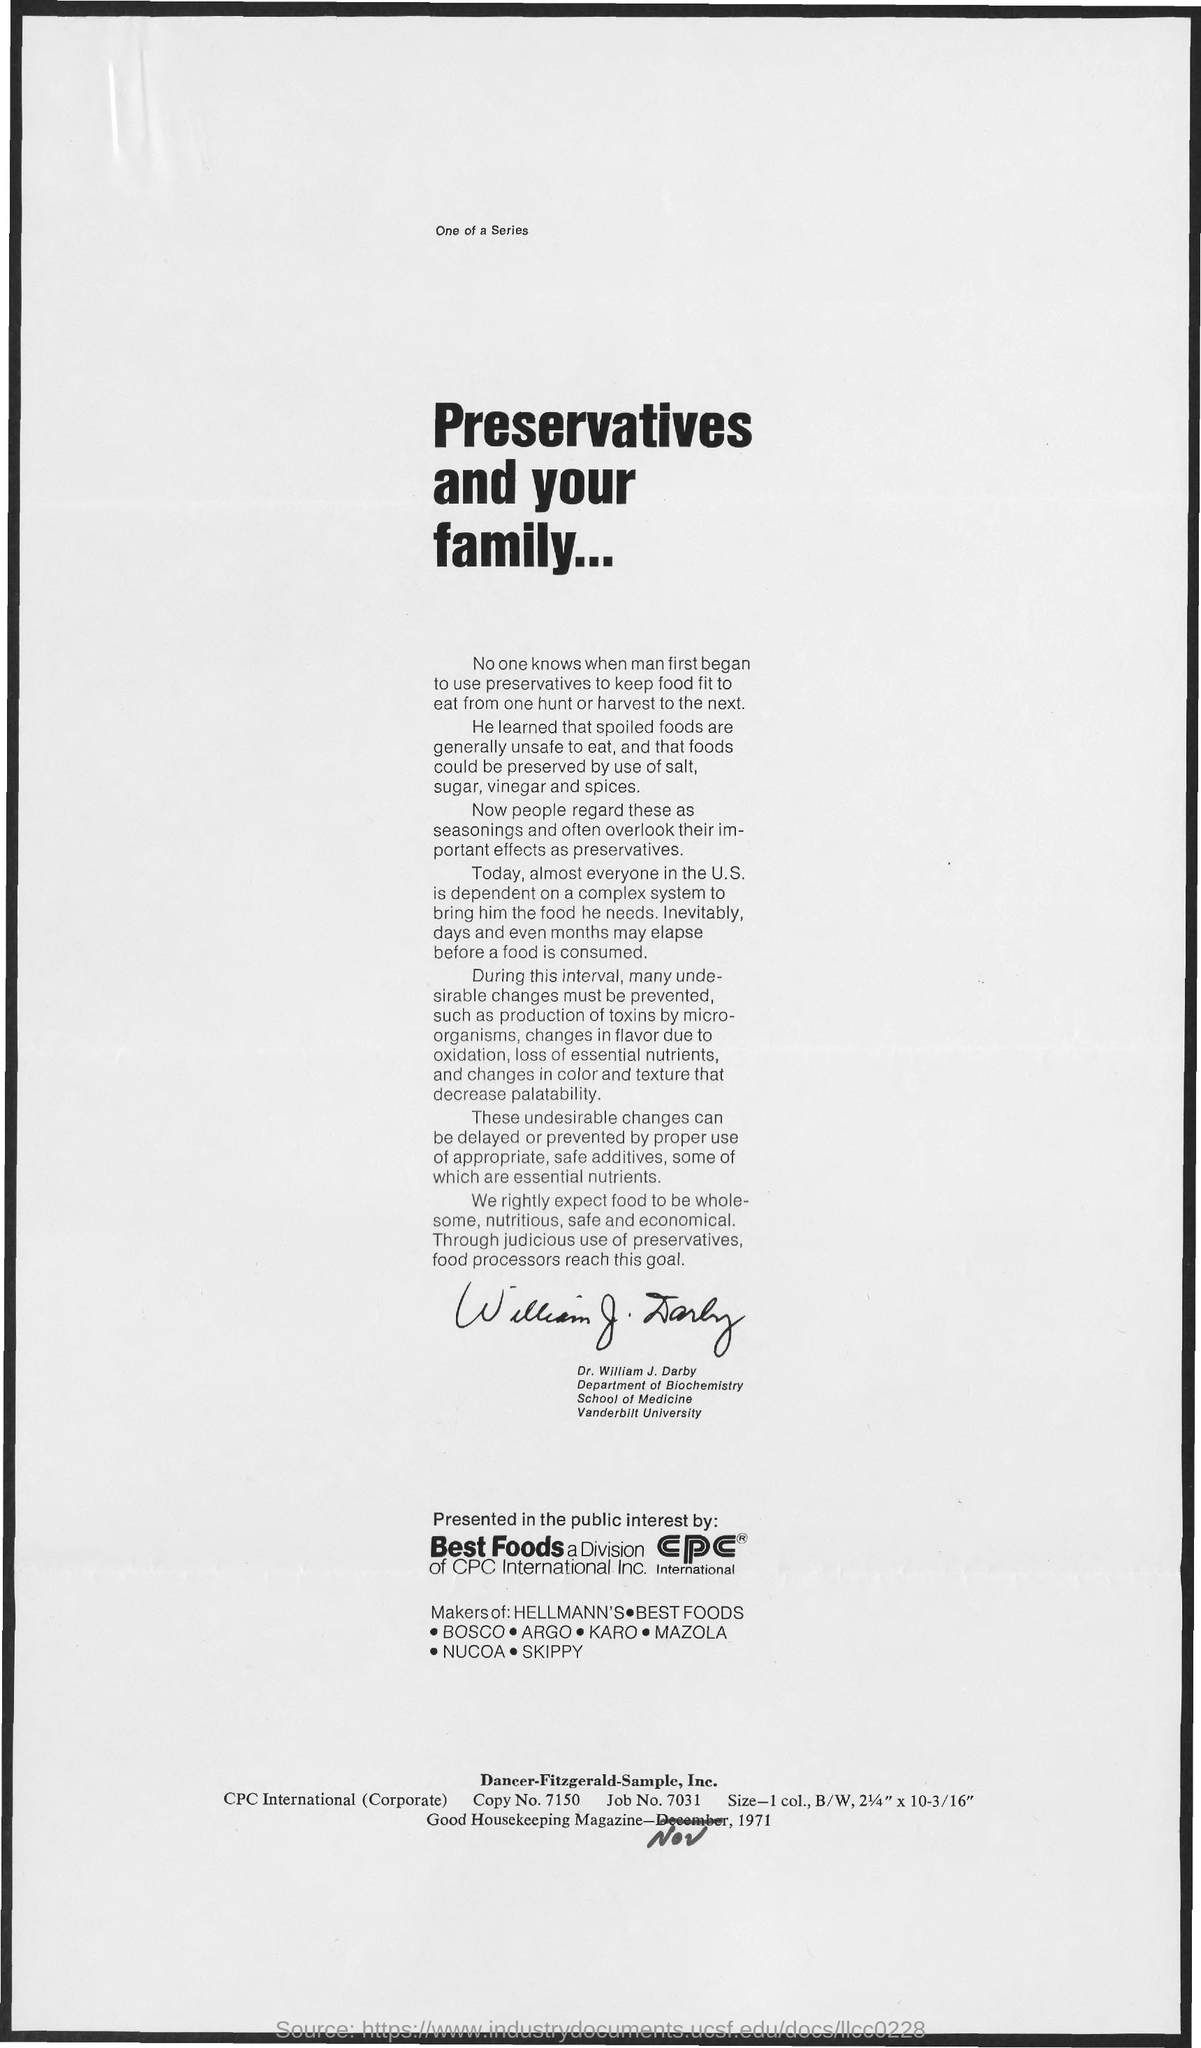What is the Title of the document?
Make the answer very short. Preservatives and your Family. 